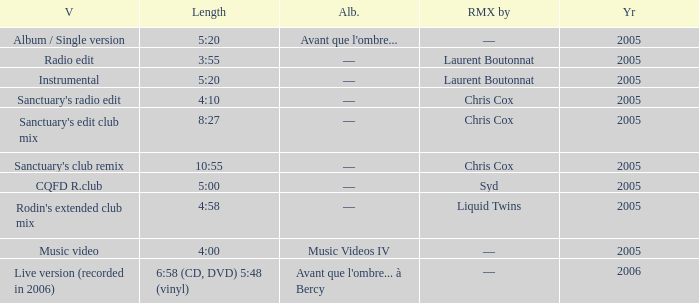What is the version shown for the Length of 4:58? Rodin's extended club mix. Can you parse all the data within this table? {'header': ['V', 'Length', 'Alb.', 'RMX by', 'Yr'], 'rows': [['Album / Single version', '5:20', "Avant que l'ombre...", '—', '2005'], ['Radio edit', '3:55', '—', 'Laurent Boutonnat', '2005'], ['Instrumental', '5:20', '—', 'Laurent Boutonnat', '2005'], ["Sanctuary's radio edit", '4:10', '—', 'Chris Cox', '2005'], ["Sanctuary's edit club mix", '8:27', '—', 'Chris Cox', '2005'], ["Sanctuary's club remix", '10:55', '—', 'Chris Cox', '2005'], ['CQFD R.club', '5:00', '—', 'Syd', '2005'], ["Rodin's extended club mix", '4:58', '—', 'Liquid Twins', '2005'], ['Music video', '4:00', 'Music Videos IV', '—', '2005'], ['Live version (recorded in 2006)', '6:58 (CD, DVD) 5:48 (vinyl)', "Avant que l'ombre... à Bercy", '—', '2006']]} 